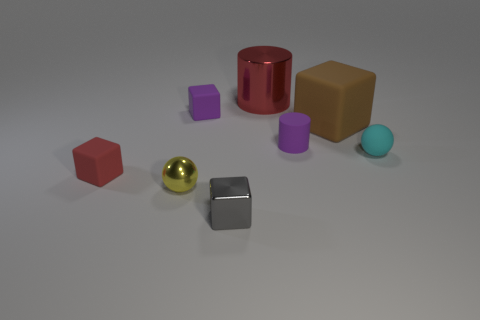Subtract all shiny cubes. How many cubes are left? 3 Add 1 brown rubber spheres. How many objects exist? 9 Subtract all cyan spheres. How many spheres are left? 1 Subtract all cylinders. How many objects are left? 6 Subtract all gray shiny blocks. Subtract all red metal cylinders. How many objects are left? 6 Add 5 gray metallic cubes. How many gray metallic cubes are left? 6 Add 7 big red matte cylinders. How many big red matte cylinders exist? 7 Subtract 1 brown cubes. How many objects are left? 7 Subtract 2 blocks. How many blocks are left? 2 Subtract all brown spheres. Subtract all brown blocks. How many spheres are left? 2 